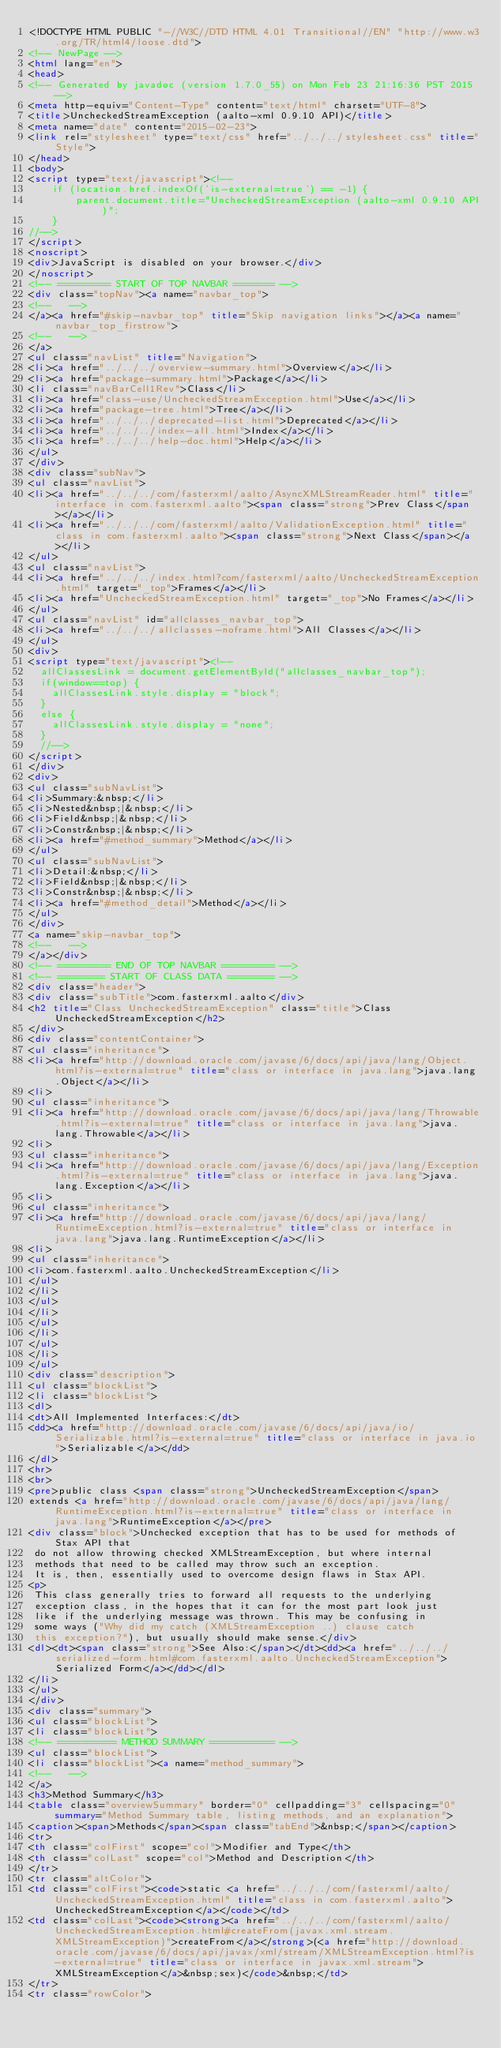<code> <loc_0><loc_0><loc_500><loc_500><_HTML_><!DOCTYPE HTML PUBLIC "-//W3C//DTD HTML 4.01 Transitional//EN" "http://www.w3.org/TR/html4/loose.dtd">
<!-- NewPage -->
<html lang="en">
<head>
<!-- Generated by javadoc (version 1.7.0_55) on Mon Feb 23 21:16:36 PST 2015 -->
<meta http-equiv="Content-Type" content="text/html" charset="UTF-8">
<title>UncheckedStreamException (aalto-xml 0.9.10 API)</title>
<meta name="date" content="2015-02-23">
<link rel="stylesheet" type="text/css" href="../../../stylesheet.css" title="Style">
</head>
<body>
<script type="text/javascript"><!--
    if (location.href.indexOf('is-external=true') == -1) {
        parent.document.title="UncheckedStreamException (aalto-xml 0.9.10 API)";
    }
//-->
</script>
<noscript>
<div>JavaScript is disabled on your browser.</div>
</noscript>
<!-- ========= START OF TOP NAVBAR ======= -->
<div class="topNav"><a name="navbar_top">
<!--   -->
</a><a href="#skip-navbar_top" title="Skip navigation links"></a><a name="navbar_top_firstrow">
<!--   -->
</a>
<ul class="navList" title="Navigation">
<li><a href="../../../overview-summary.html">Overview</a></li>
<li><a href="package-summary.html">Package</a></li>
<li class="navBarCell1Rev">Class</li>
<li><a href="class-use/UncheckedStreamException.html">Use</a></li>
<li><a href="package-tree.html">Tree</a></li>
<li><a href="../../../deprecated-list.html">Deprecated</a></li>
<li><a href="../../../index-all.html">Index</a></li>
<li><a href="../../../help-doc.html">Help</a></li>
</ul>
</div>
<div class="subNav">
<ul class="navList">
<li><a href="../../../com/fasterxml/aalto/AsyncXMLStreamReader.html" title="interface in com.fasterxml.aalto"><span class="strong">Prev Class</span></a></li>
<li><a href="../../../com/fasterxml/aalto/ValidationException.html" title="class in com.fasterxml.aalto"><span class="strong">Next Class</span></a></li>
</ul>
<ul class="navList">
<li><a href="../../../index.html?com/fasterxml/aalto/UncheckedStreamException.html" target="_top">Frames</a></li>
<li><a href="UncheckedStreamException.html" target="_top">No Frames</a></li>
</ul>
<ul class="navList" id="allclasses_navbar_top">
<li><a href="../../../allclasses-noframe.html">All Classes</a></li>
</ul>
<div>
<script type="text/javascript"><!--
  allClassesLink = document.getElementById("allclasses_navbar_top");
  if(window==top) {
    allClassesLink.style.display = "block";
  }
  else {
    allClassesLink.style.display = "none";
  }
  //-->
</script>
</div>
<div>
<ul class="subNavList">
<li>Summary:&nbsp;</li>
<li>Nested&nbsp;|&nbsp;</li>
<li>Field&nbsp;|&nbsp;</li>
<li>Constr&nbsp;|&nbsp;</li>
<li><a href="#method_summary">Method</a></li>
</ul>
<ul class="subNavList">
<li>Detail:&nbsp;</li>
<li>Field&nbsp;|&nbsp;</li>
<li>Constr&nbsp;|&nbsp;</li>
<li><a href="#method_detail">Method</a></li>
</ul>
</div>
<a name="skip-navbar_top">
<!--   -->
</a></div>
<!-- ========= END OF TOP NAVBAR ========= -->
<!-- ======== START OF CLASS DATA ======== -->
<div class="header">
<div class="subTitle">com.fasterxml.aalto</div>
<h2 title="Class UncheckedStreamException" class="title">Class UncheckedStreamException</h2>
</div>
<div class="contentContainer">
<ul class="inheritance">
<li><a href="http://download.oracle.com/javase/6/docs/api/java/lang/Object.html?is-external=true" title="class or interface in java.lang">java.lang.Object</a></li>
<li>
<ul class="inheritance">
<li><a href="http://download.oracle.com/javase/6/docs/api/java/lang/Throwable.html?is-external=true" title="class or interface in java.lang">java.lang.Throwable</a></li>
<li>
<ul class="inheritance">
<li><a href="http://download.oracle.com/javase/6/docs/api/java/lang/Exception.html?is-external=true" title="class or interface in java.lang">java.lang.Exception</a></li>
<li>
<ul class="inheritance">
<li><a href="http://download.oracle.com/javase/6/docs/api/java/lang/RuntimeException.html?is-external=true" title="class or interface in java.lang">java.lang.RuntimeException</a></li>
<li>
<ul class="inheritance">
<li>com.fasterxml.aalto.UncheckedStreamException</li>
</ul>
</li>
</ul>
</li>
</ul>
</li>
</ul>
</li>
</ul>
<div class="description">
<ul class="blockList">
<li class="blockList">
<dl>
<dt>All Implemented Interfaces:</dt>
<dd><a href="http://download.oracle.com/javase/6/docs/api/java/io/Serializable.html?is-external=true" title="class or interface in java.io">Serializable</a></dd>
</dl>
<hr>
<br>
<pre>public class <span class="strong">UncheckedStreamException</span>
extends <a href="http://download.oracle.com/javase/6/docs/api/java/lang/RuntimeException.html?is-external=true" title="class or interface in java.lang">RuntimeException</a></pre>
<div class="block">Unchecked exception that has to be used for methods of Stax API that
 do not allow throwing checked XMLStreamException, but where internal
 methods that need to be called may throw such an exception.
 It is, then, essentially used to overcome design flaws in Stax API.
<p>
 This class generally tries to forward all requests to the underlying
 exception class, in the hopes that it can for the most part look just
 like if the underlying message was thrown. This may be confusing in
 some ways ("Why did my catch (XMLStreamException ..) clause catch
 this exception?"), but usually should make sense.</div>
<dl><dt><span class="strong">See Also:</span></dt><dd><a href="../../../serialized-form.html#com.fasterxml.aalto.UncheckedStreamException">Serialized Form</a></dd></dl>
</li>
</ul>
</div>
<div class="summary">
<ul class="blockList">
<li class="blockList">
<!-- ========== METHOD SUMMARY =========== -->
<ul class="blockList">
<li class="blockList"><a name="method_summary">
<!--   -->
</a>
<h3>Method Summary</h3>
<table class="overviewSummary" border="0" cellpadding="3" cellspacing="0" summary="Method Summary table, listing methods, and an explanation">
<caption><span>Methods</span><span class="tabEnd">&nbsp;</span></caption>
<tr>
<th class="colFirst" scope="col">Modifier and Type</th>
<th class="colLast" scope="col">Method and Description</th>
</tr>
<tr class="altColor">
<td class="colFirst"><code>static <a href="../../../com/fasterxml/aalto/UncheckedStreamException.html" title="class in com.fasterxml.aalto">UncheckedStreamException</a></code></td>
<td class="colLast"><code><strong><a href="../../../com/fasterxml/aalto/UncheckedStreamException.html#createFrom(javax.xml.stream.XMLStreamException)">createFrom</a></strong>(<a href="http://download.oracle.com/javase/6/docs/api/javax/xml/stream/XMLStreamException.html?is-external=true" title="class or interface in javax.xml.stream">XMLStreamException</a>&nbsp;sex)</code>&nbsp;</td>
</tr>
<tr class="rowColor"></code> 